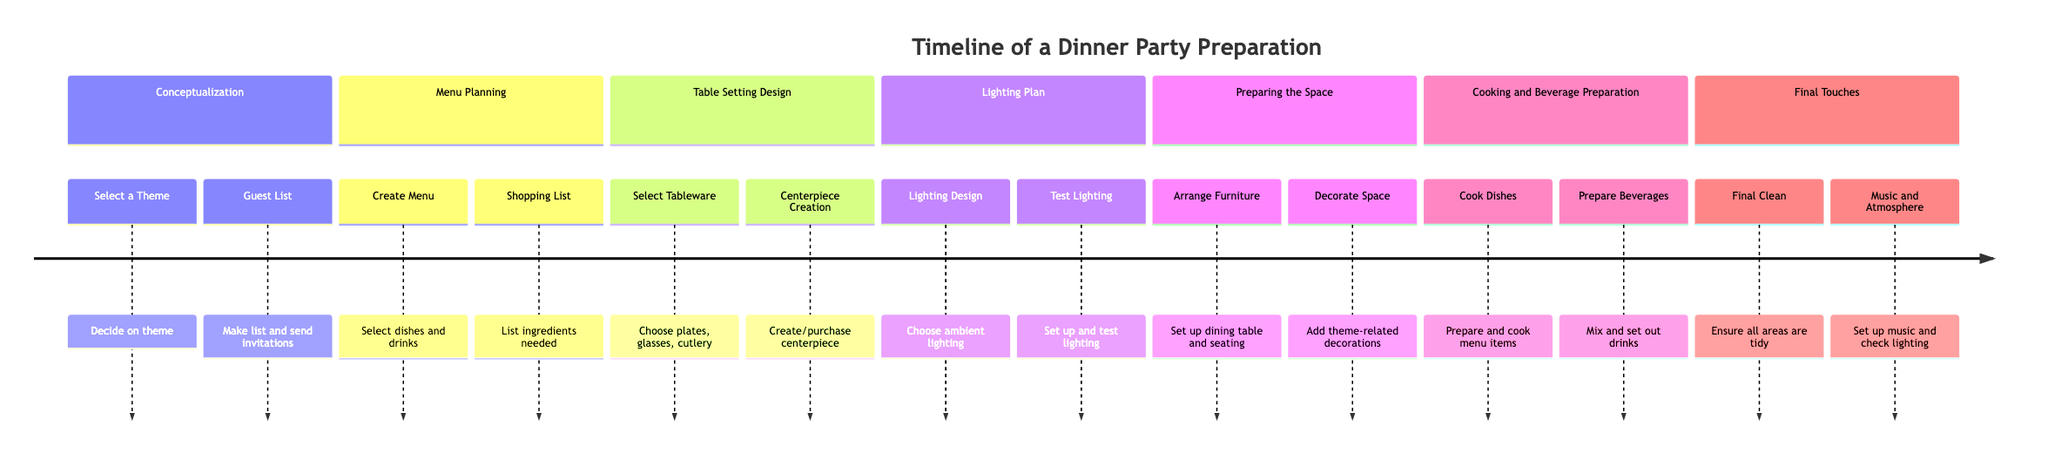What is the first stage in the dinner party preparation timeline? The timeline begins with the "Conceptualization" stage, as it's the first section listed before the others.
Answer: Conceptualization How many tasks are listed under the "Menu Planning" stage? There are two tasks listed under the "Menu Planning" stage: "Create Menu" and "Shopping List." Therefore, the count of tasks is two.
Answer: 2 Which task comes last in the timeline? The last task in the timeline is "Music and Atmosphere," which is under the "Final Touches" stage. It is the final element listed in the sequence of tasks.
Answer: Music and Atmosphere What is the purpose of the "Lighting Plan" stage? The "Lighting Plan" stage is about deciding on the mood lighting for the party atmosphere, as described in the stage's explanation.
Answer: Deciding on mood lighting In which stage would you find tasks related to setting up the dining area? The tasks related to setting up the dining area are found in the "Preparing the Space" stage, where tasks like "Arrange Furniture" and "Decorate Space" are mentioned.
Answer: Preparing the Space What element is part of the "Final Touches" stage in terms of cleanliness? The task that pertains to cleanliness in the "Final Touches" stage is "Final Clean," which emphasizes the importance of tidying up before guests arrive.
Answer: Final Clean Which two tasks involve selection and creation in the dining party preparation? The two tasks that involve selection and creation are "Select Tableware" from the "Table Setting Design" stage and "Centerpiece Creation" also from the same stage, emphasizing decor choices.
Answer: Select Tableware, Centerpiece Creation How does the "Cooking and Beverage Preparation" stage relate to menu planning? The "Cooking and Beverage Preparation" stage directly follows "Menu Planning" in the timeline, indicating that after planning the menu, the next step involves the actual preparation of the items selected.
Answer: Follows directly after What is emphasized in the "Final Touches" stage regarding the atmosphere? The "Final Touches" stage emphasizes setting up background music and checking the ambiance lighting to ensure a pleasing environment for guests.
Answer: Background music and ambiance lighting 